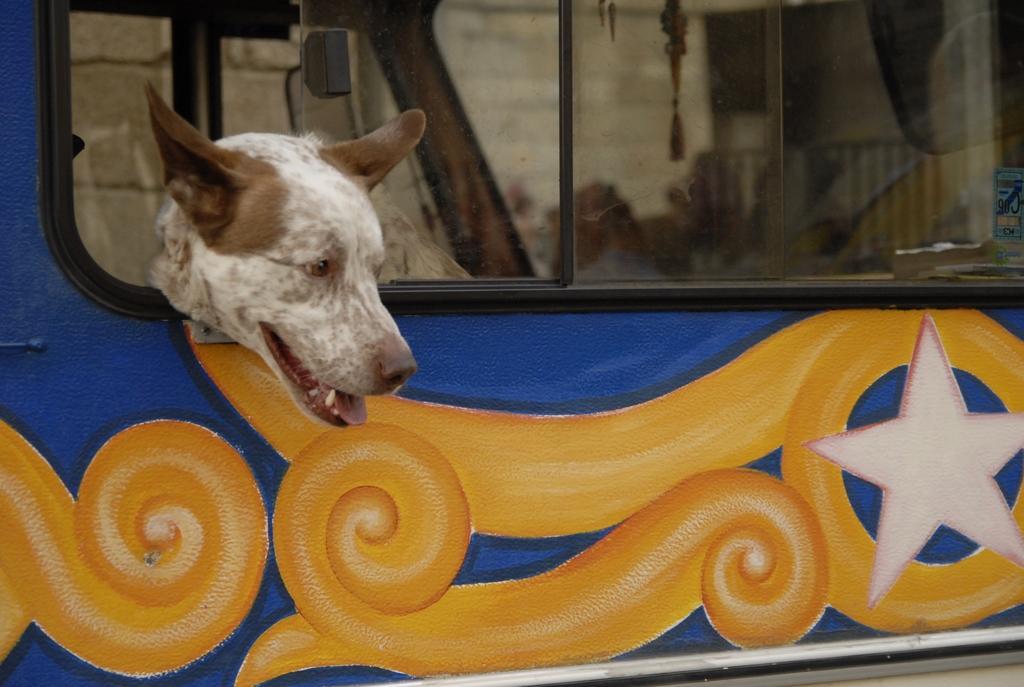Describe this image in one or two sentences. In this image a dog is in the vehicle. Dog is keeping its head out of the window of a vehicle. Behind the vehicle there's a wall. On the vehicle there is some design painted on it. 